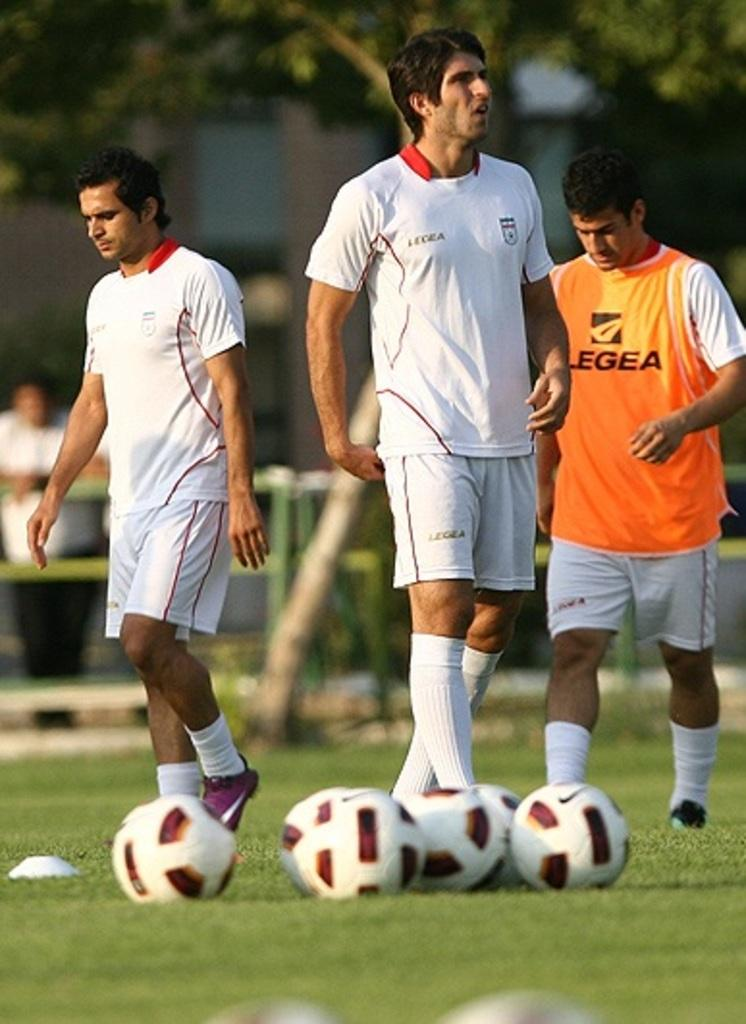How many people are in the image? There are three persons in the image. What are the persons wearing? The persons are wearing clothes. What are the persons doing in the image? The persons are walking on the ground. What objects can be seen at the bottom of the image? There are some balls at the bottom of the image. Can you describe the background of the image? The background of the image is blurred. What is the suggestion made by the downtown area in the image? There is no downtown area present in the image, so it cannot make any suggestions. 